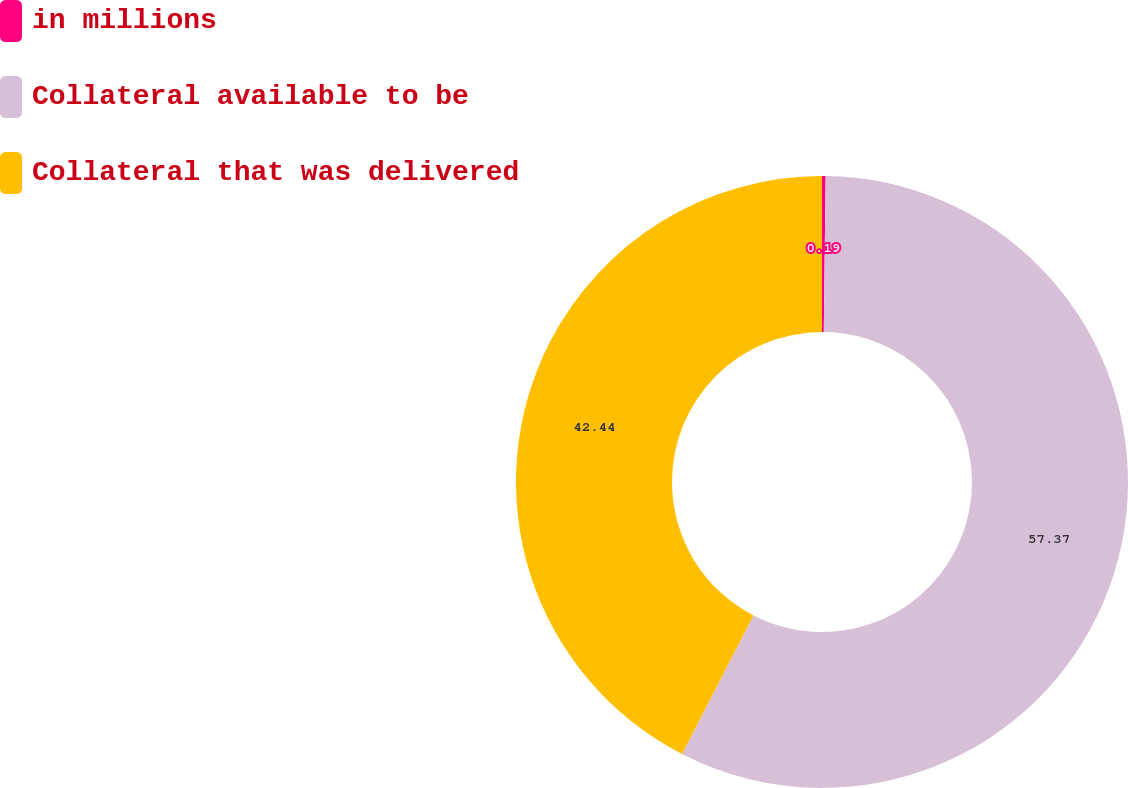Convert chart to OTSL. <chart><loc_0><loc_0><loc_500><loc_500><pie_chart><fcel>in millions<fcel>Collateral available to be<fcel>Collateral that was delivered<nl><fcel>0.19%<fcel>57.37%<fcel>42.44%<nl></chart> 